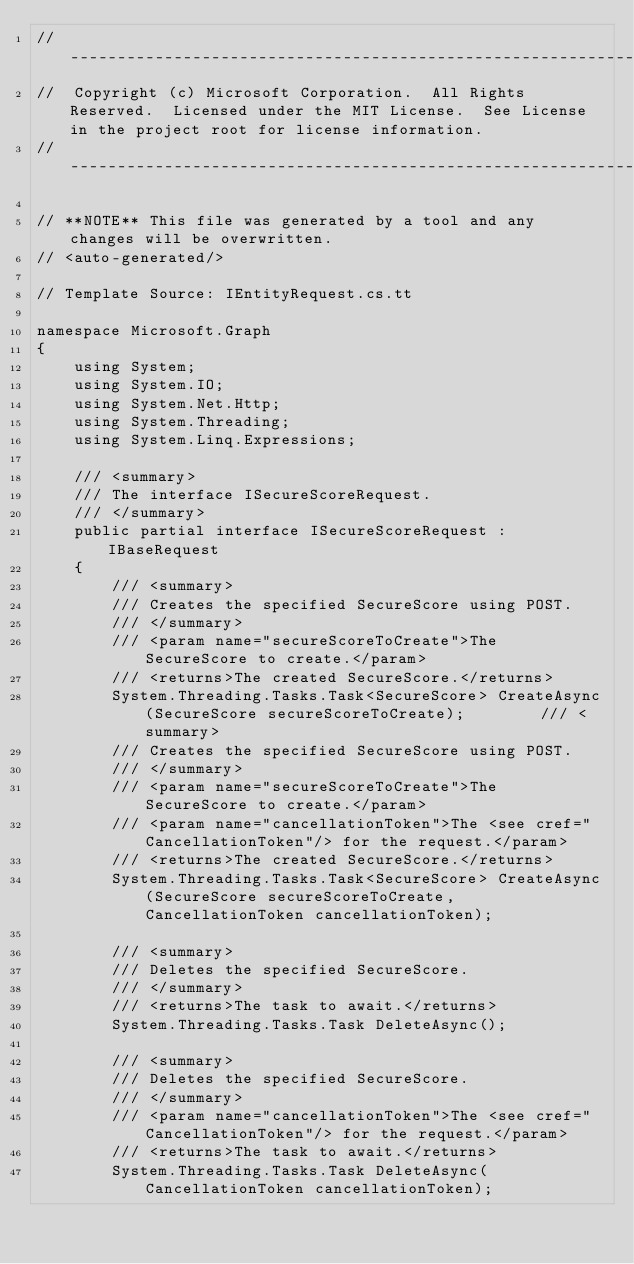<code> <loc_0><loc_0><loc_500><loc_500><_C#_>// ------------------------------------------------------------------------------
//  Copyright (c) Microsoft Corporation.  All Rights Reserved.  Licensed under the MIT License.  See License in the project root for license information.
// ------------------------------------------------------------------------------

// **NOTE** This file was generated by a tool and any changes will be overwritten.
// <auto-generated/>

// Template Source: IEntityRequest.cs.tt

namespace Microsoft.Graph
{
    using System;
    using System.IO;
    using System.Net.Http;
    using System.Threading;
    using System.Linq.Expressions;

    /// <summary>
    /// The interface ISecureScoreRequest.
    /// </summary>
    public partial interface ISecureScoreRequest : IBaseRequest
    {
        /// <summary>
        /// Creates the specified SecureScore using POST.
        /// </summary>
        /// <param name="secureScoreToCreate">The SecureScore to create.</param>
        /// <returns>The created SecureScore.</returns>
        System.Threading.Tasks.Task<SecureScore> CreateAsync(SecureScore secureScoreToCreate);        /// <summary>
        /// Creates the specified SecureScore using POST.
        /// </summary>
        /// <param name="secureScoreToCreate">The SecureScore to create.</param>
        /// <param name="cancellationToken">The <see cref="CancellationToken"/> for the request.</param>
        /// <returns>The created SecureScore.</returns>
        System.Threading.Tasks.Task<SecureScore> CreateAsync(SecureScore secureScoreToCreate, CancellationToken cancellationToken);

        /// <summary>
        /// Deletes the specified SecureScore.
        /// </summary>
        /// <returns>The task to await.</returns>
        System.Threading.Tasks.Task DeleteAsync();

        /// <summary>
        /// Deletes the specified SecureScore.
        /// </summary>
        /// <param name="cancellationToken">The <see cref="CancellationToken"/> for the request.</param>
        /// <returns>The task to await.</returns>
        System.Threading.Tasks.Task DeleteAsync(CancellationToken cancellationToken);
</code> 